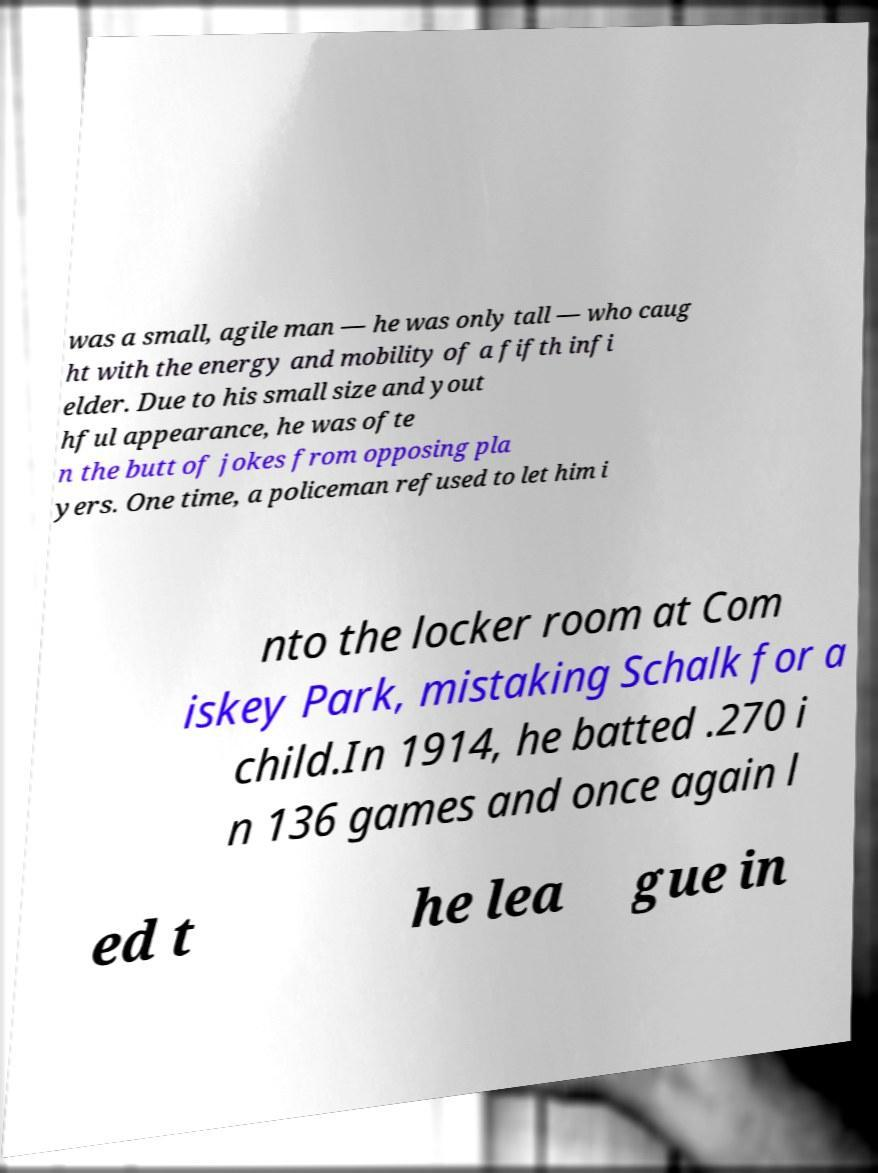Can you read and provide the text displayed in the image?This photo seems to have some interesting text. Can you extract and type it out for me? was a small, agile man — he was only tall — who caug ht with the energy and mobility of a fifth infi elder. Due to his small size and yout hful appearance, he was ofte n the butt of jokes from opposing pla yers. One time, a policeman refused to let him i nto the locker room at Com iskey Park, mistaking Schalk for a child.In 1914, he batted .270 i n 136 games and once again l ed t he lea gue in 